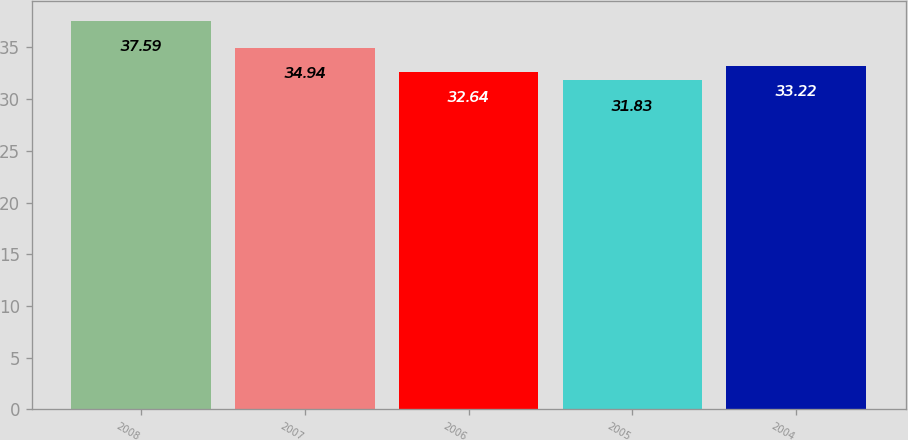<chart> <loc_0><loc_0><loc_500><loc_500><bar_chart><fcel>2008<fcel>2007<fcel>2006<fcel>2005<fcel>2004<nl><fcel>37.59<fcel>34.94<fcel>32.64<fcel>31.83<fcel>33.22<nl></chart> 